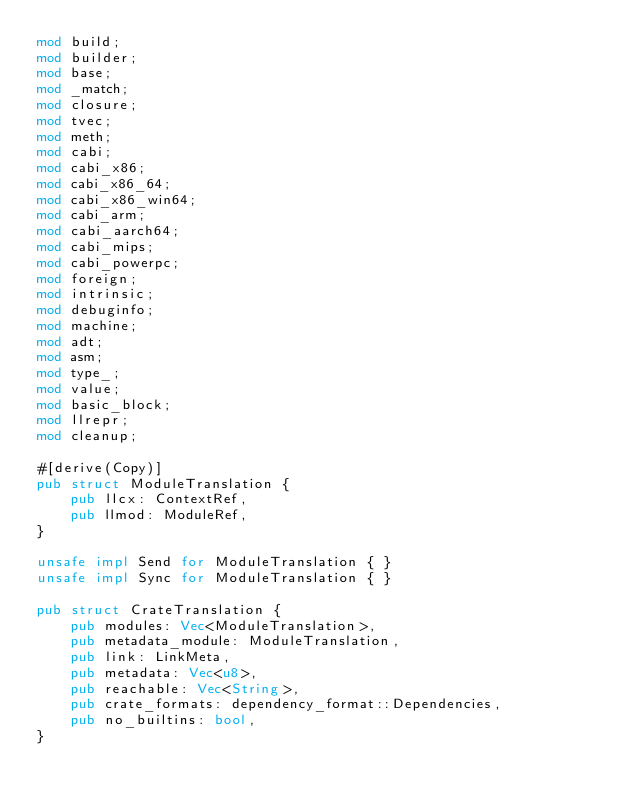Convert code to text. <code><loc_0><loc_0><loc_500><loc_500><_Rust_>mod build;
mod builder;
mod base;
mod _match;
mod closure;
mod tvec;
mod meth;
mod cabi;
mod cabi_x86;
mod cabi_x86_64;
mod cabi_x86_win64;
mod cabi_arm;
mod cabi_aarch64;
mod cabi_mips;
mod cabi_powerpc;
mod foreign;
mod intrinsic;
mod debuginfo;
mod machine;
mod adt;
mod asm;
mod type_;
mod value;
mod basic_block;
mod llrepr;
mod cleanup;

#[derive(Copy)]
pub struct ModuleTranslation {
    pub llcx: ContextRef,
    pub llmod: ModuleRef,
}

unsafe impl Send for ModuleTranslation { }
unsafe impl Sync for ModuleTranslation { }

pub struct CrateTranslation {
    pub modules: Vec<ModuleTranslation>,
    pub metadata_module: ModuleTranslation,
    pub link: LinkMeta,
    pub metadata: Vec<u8>,
    pub reachable: Vec<String>,
    pub crate_formats: dependency_format::Dependencies,
    pub no_builtins: bool,
}
</code> 